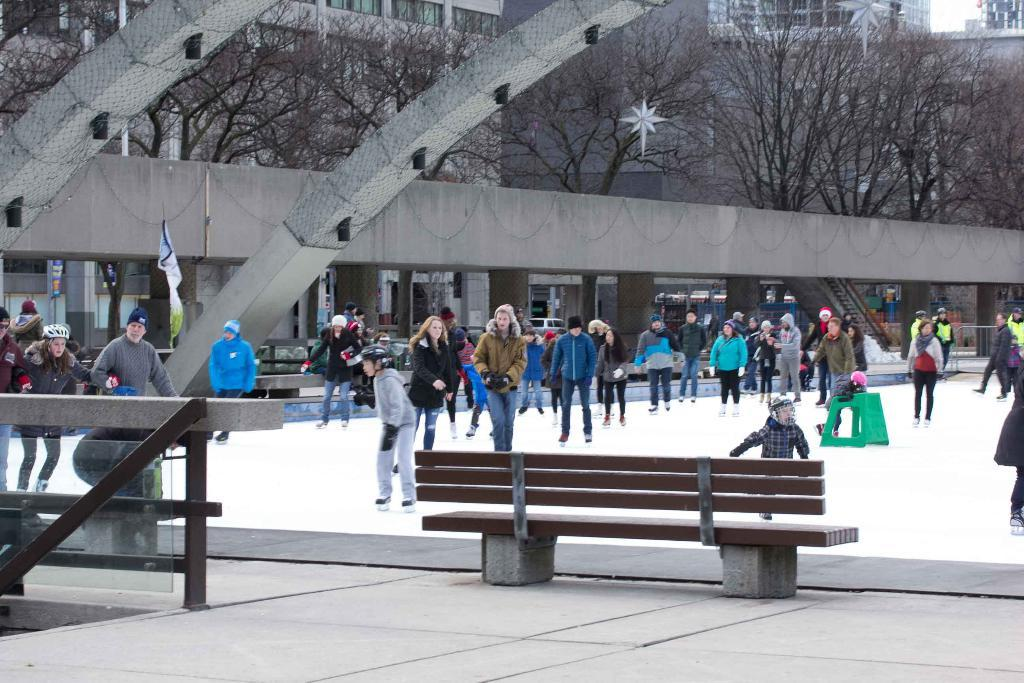What are the persons skating on ice wearing? The skaters are wearing skating on ice are wearing skating shoes. What can be seen in the background of the image? There are bare trees and buildings visible in the image. What object is in front of a person in the image? There is a bench in front of a person in the image. Who is the owner of the ice rink in the image? There is no information about the owner of the ice rink in the image. Can you tell me how many friends are skating with the person in the image? There is no information about friends or the number of people skating in the image; only the presence of persons skating on ice is mentioned. 